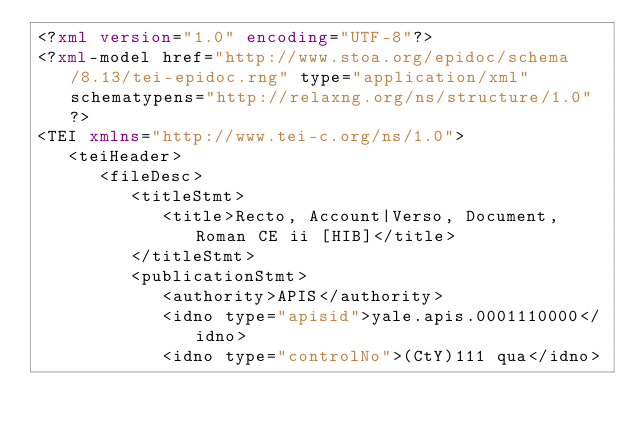<code> <loc_0><loc_0><loc_500><loc_500><_XML_><?xml version="1.0" encoding="UTF-8"?>
<?xml-model href="http://www.stoa.org/epidoc/schema/8.13/tei-epidoc.rng" type="application/xml" schematypens="http://relaxng.org/ns/structure/1.0"?>
<TEI xmlns="http://www.tei-c.org/ns/1.0">
   <teiHeader>
      <fileDesc>
         <titleStmt>
            <title>Recto, Account|Verso, Document, Roman CE ii [HIB]</title>
         </titleStmt>
         <publicationStmt>
            <authority>APIS</authority>
            <idno type="apisid">yale.apis.0001110000</idno>
            <idno type="controlNo">(CtY)111 qua</idno></code> 